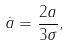Convert formula to latex. <formula><loc_0><loc_0><loc_500><loc_500>\dot { a } = \frac { 2 a } { 3 \sigma } ,</formula> 